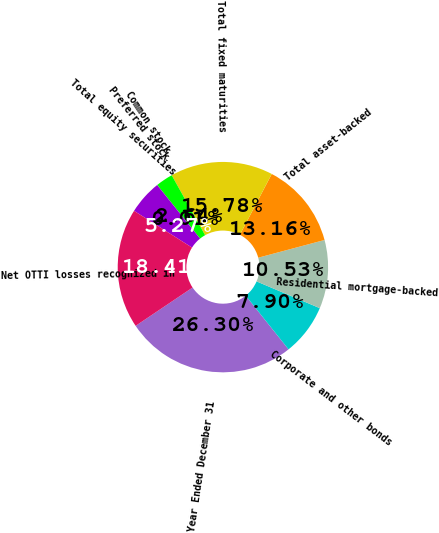<chart> <loc_0><loc_0><loc_500><loc_500><pie_chart><fcel>Year Ended December 31<fcel>Corporate and other bonds<fcel>Residential mortgage-backed<fcel>Total asset-backed<fcel>Total fixed maturities<fcel>Common stock<fcel>Preferred stock<fcel>Total equity securities<fcel>Net OTTI losses recognized in<nl><fcel>26.3%<fcel>7.9%<fcel>10.53%<fcel>13.16%<fcel>15.78%<fcel>2.64%<fcel>0.01%<fcel>5.27%<fcel>18.41%<nl></chart> 